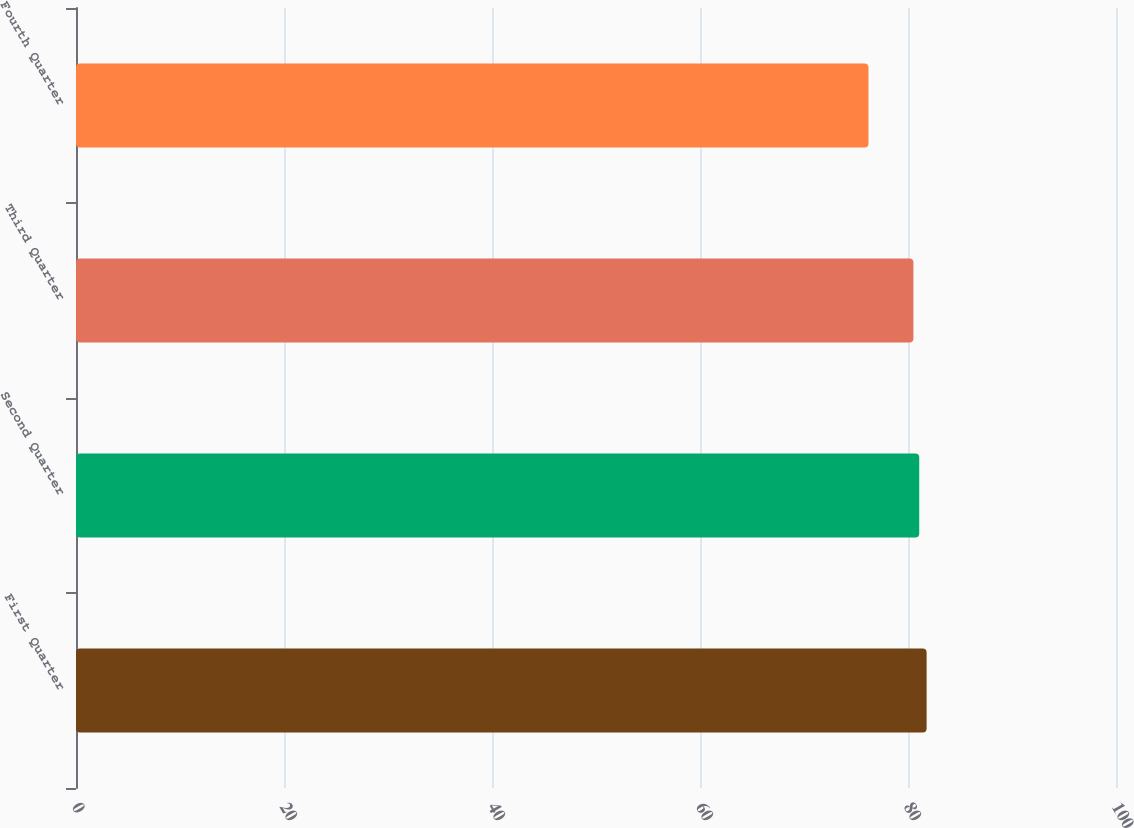Convert chart to OTSL. <chart><loc_0><loc_0><loc_500><loc_500><bar_chart><fcel>First Quarter<fcel>Second Quarter<fcel>Third Quarter<fcel>Fourth Quarter<nl><fcel>81.79<fcel>81.08<fcel>80.52<fcel>76.2<nl></chart> 